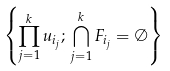Convert formula to latex. <formula><loc_0><loc_0><loc_500><loc_500>\left \{ \prod _ { j = 1 } ^ { k } u _ { i _ { j } } ; \, \bigcap _ { j = 1 } ^ { k } F _ { i _ { j } } = \emptyset \right \}</formula> 